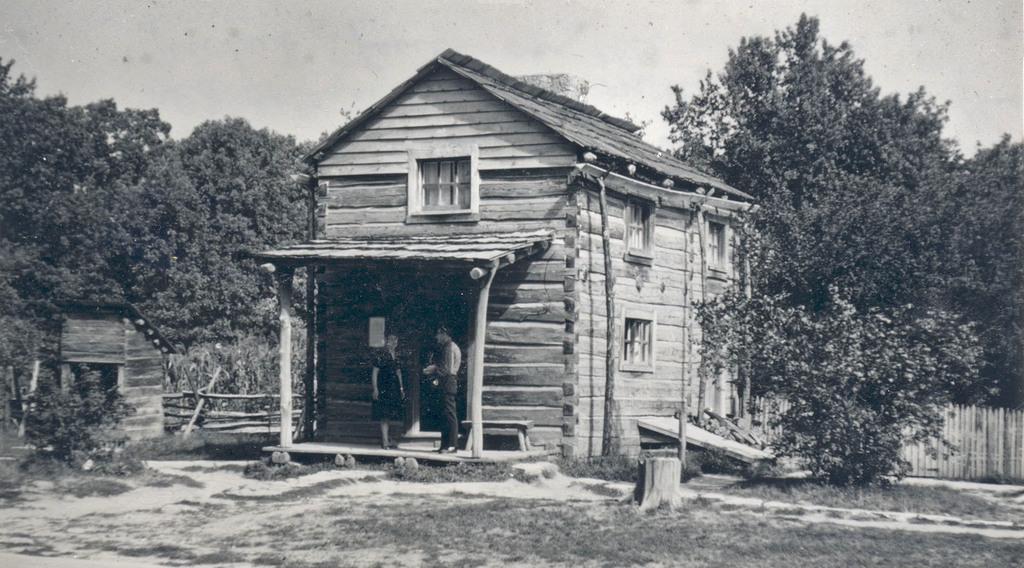Could you give a brief overview of what you see in this image? This is a black and white image , where there are two persons , houses, plants, trees, fence, and in the background there is sky. 